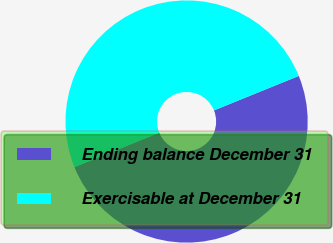Convert chart. <chart><loc_0><loc_0><loc_500><loc_500><pie_chart><fcel>Ending balance December 31<fcel>Exercisable at December 31<nl><fcel>50.0%<fcel>50.0%<nl></chart> 